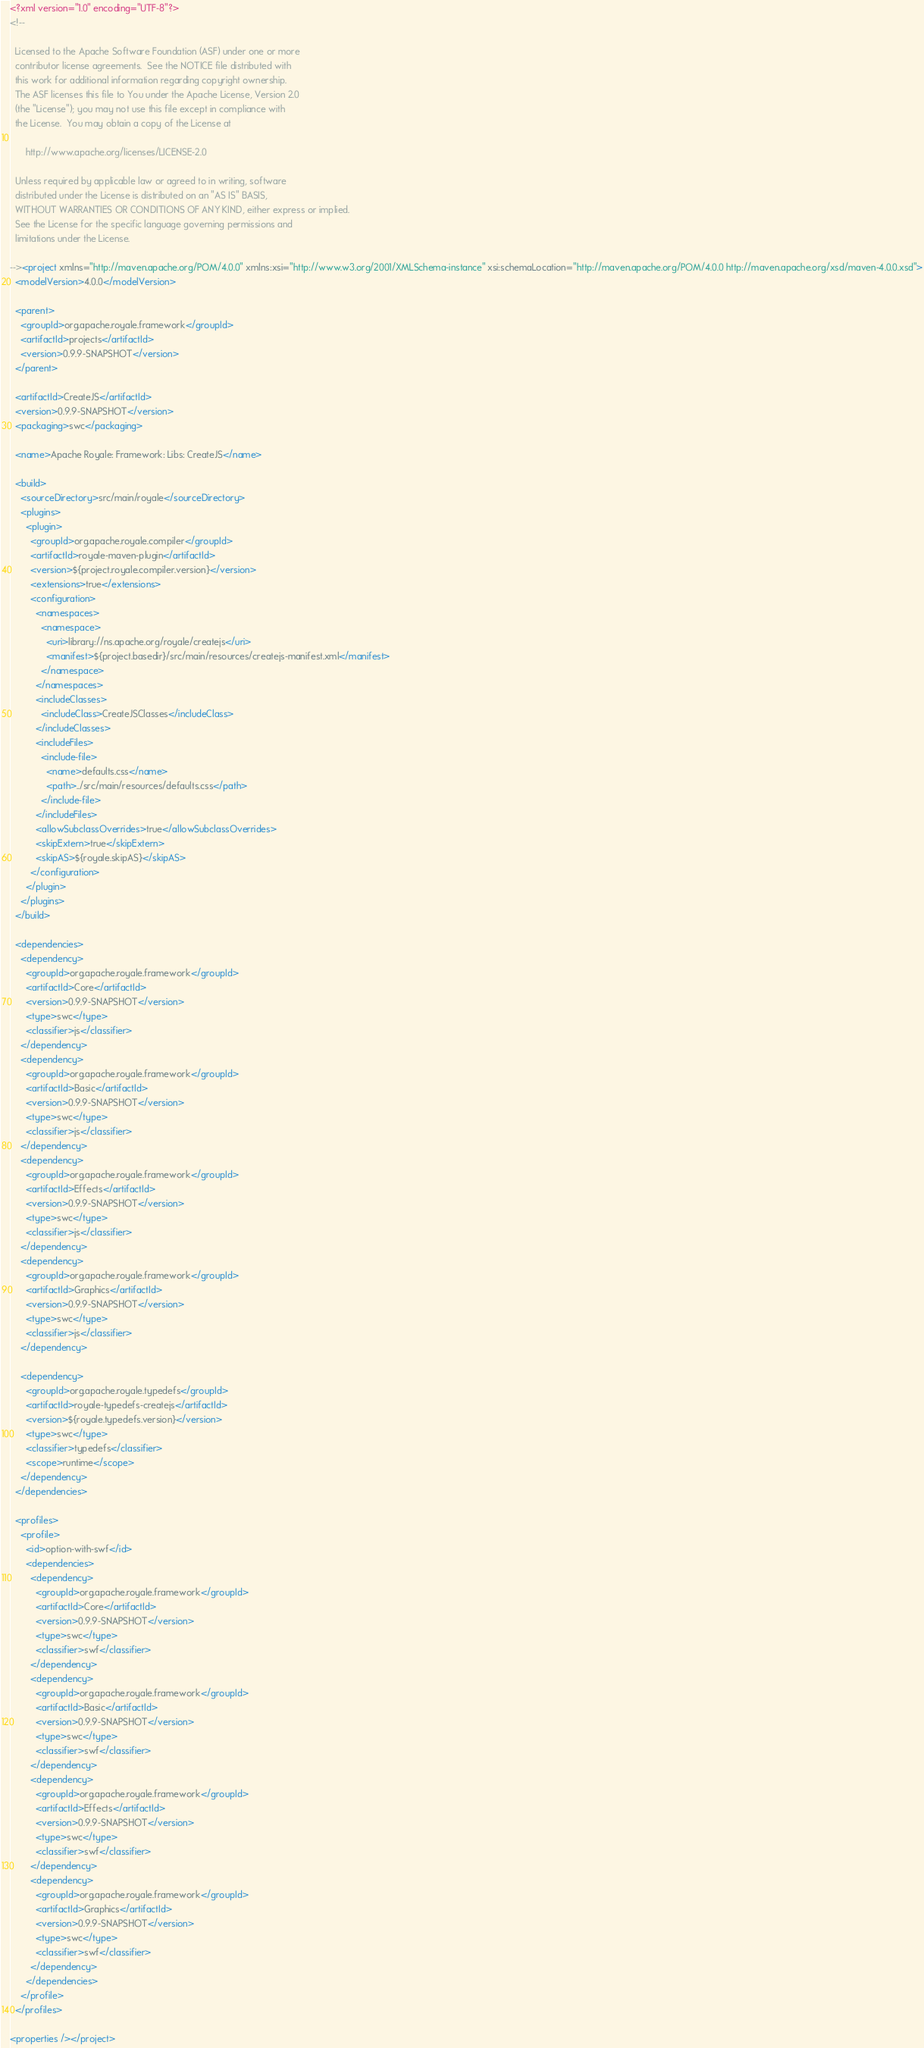Convert code to text. <code><loc_0><loc_0><loc_500><loc_500><_XML_><?xml version="1.0" encoding="UTF-8"?>
<!--

  Licensed to the Apache Software Foundation (ASF) under one or more
  contributor license agreements.  See the NOTICE file distributed with
  this work for additional information regarding copyright ownership.
  The ASF licenses this file to You under the Apache License, Version 2.0
  (the "License"); you may not use this file except in compliance with
  the License.  You may obtain a copy of the License at

      http://www.apache.org/licenses/LICENSE-2.0

  Unless required by applicable law or agreed to in writing, software
  distributed under the License is distributed on an "AS IS" BASIS,
  WITHOUT WARRANTIES OR CONDITIONS OF ANY KIND, either express or implied.
  See the License for the specific language governing permissions and
  limitations under the License.

--><project xmlns="http://maven.apache.org/POM/4.0.0" xmlns:xsi="http://www.w3.org/2001/XMLSchema-instance" xsi:schemaLocation="http://maven.apache.org/POM/4.0.0 http://maven.apache.org/xsd/maven-4.0.0.xsd">
  <modelVersion>4.0.0</modelVersion>

  <parent>
    <groupId>org.apache.royale.framework</groupId>
    <artifactId>projects</artifactId>
    <version>0.9.9-SNAPSHOT</version>
  </parent>

  <artifactId>CreateJS</artifactId>
  <version>0.9.9-SNAPSHOT</version>
  <packaging>swc</packaging>

  <name>Apache Royale: Framework: Libs: CreateJS</name>

  <build>
    <sourceDirectory>src/main/royale</sourceDirectory>
    <plugins>
      <plugin>
        <groupId>org.apache.royale.compiler</groupId>
        <artifactId>royale-maven-plugin</artifactId>
        <version>${project.royale.compiler.version}</version>
        <extensions>true</extensions>
        <configuration>
          <namespaces>
            <namespace>
              <uri>library://ns.apache.org/royale/createjs</uri>
              <manifest>${project.basedir}/src/main/resources/createjs-manifest.xml</manifest>
            </namespace>
          </namespaces>
          <includeClasses>
            <includeClass>CreateJSClasses</includeClass>
          </includeClasses>
          <includeFiles>
            <include-file>
              <name>defaults.css</name>
              <path>../src/main/resources/defaults.css</path>
            </include-file>
          </includeFiles>
          <allowSubclassOverrides>true</allowSubclassOverrides>
          <skipExtern>true</skipExtern>
          <skipAS>${royale.skipAS}</skipAS>
        </configuration>
      </plugin>
    </plugins>
  </build>
  
  <dependencies>
    <dependency>
      <groupId>org.apache.royale.framework</groupId>
      <artifactId>Core</artifactId>
      <version>0.9.9-SNAPSHOT</version>
      <type>swc</type>
      <classifier>js</classifier>
    </dependency>
    <dependency>
      <groupId>org.apache.royale.framework</groupId>
      <artifactId>Basic</artifactId>
      <version>0.9.9-SNAPSHOT</version>
      <type>swc</type>
      <classifier>js</classifier>
    </dependency>
    <dependency>
      <groupId>org.apache.royale.framework</groupId>
      <artifactId>Effects</artifactId>
      <version>0.9.9-SNAPSHOT</version>
      <type>swc</type>
      <classifier>js</classifier>
    </dependency>
    <dependency>
      <groupId>org.apache.royale.framework</groupId>
      <artifactId>Graphics</artifactId>
      <version>0.9.9-SNAPSHOT</version>
      <type>swc</type>
      <classifier>js</classifier>
    </dependency>

    <dependency>
      <groupId>org.apache.royale.typedefs</groupId>
      <artifactId>royale-typedefs-createjs</artifactId>
      <version>${royale.typedefs.version}</version>
      <type>swc</type>
      <classifier>typedefs</classifier>
      <scope>runtime</scope>
    </dependency>
  </dependencies>

  <profiles>
    <profile>
      <id>option-with-swf</id>
      <dependencies>
        <dependency>
          <groupId>org.apache.royale.framework</groupId>
          <artifactId>Core</artifactId>
          <version>0.9.9-SNAPSHOT</version>
          <type>swc</type>
          <classifier>swf</classifier>
        </dependency>
        <dependency>
          <groupId>org.apache.royale.framework</groupId>
          <artifactId>Basic</artifactId>
          <version>0.9.9-SNAPSHOT</version>
          <type>swc</type>
          <classifier>swf</classifier>
        </dependency>
        <dependency>
          <groupId>org.apache.royale.framework</groupId>
          <artifactId>Effects</artifactId>
          <version>0.9.9-SNAPSHOT</version>
          <type>swc</type>
          <classifier>swf</classifier>
        </dependency>
        <dependency>
          <groupId>org.apache.royale.framework</groupId>
          <artifactId>Graphics</artifactId>
          <version>0.9.9-SNAPSHOT</version>
          <type>swc</type>
          <classifier>swf</classifier>
        </dependency>
      </dependencies>
    </profile>
  </profiles>

<properties /></project>
</code> 